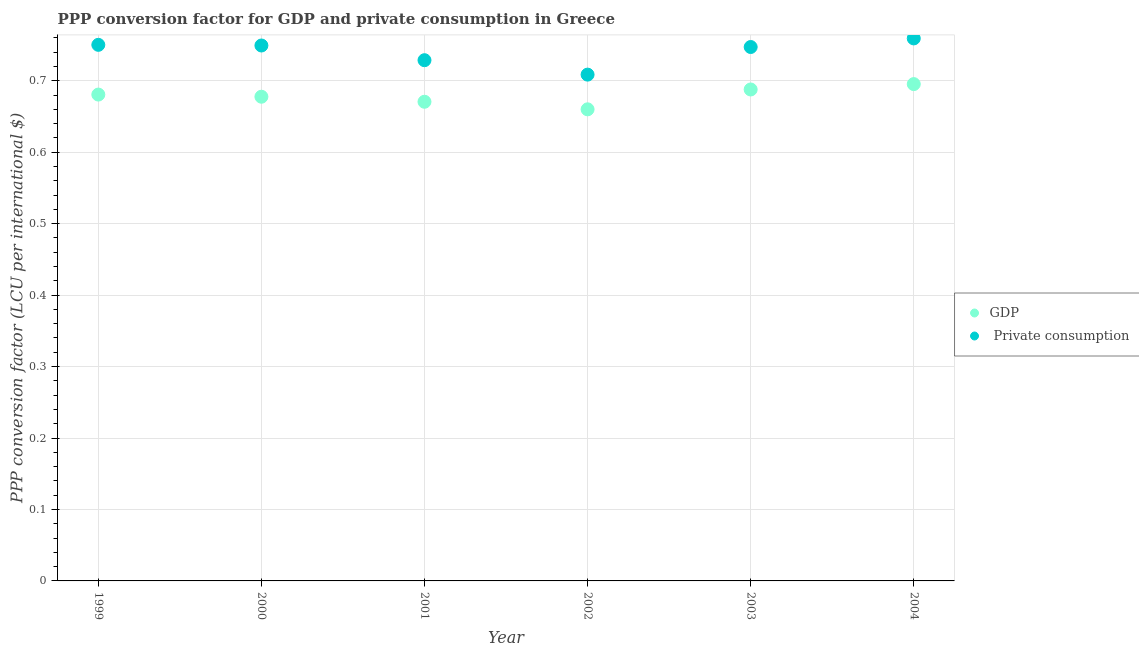How many different coloured dotlines are there?
Offer a very short reply. 2. Is the number of dotlines equal to the number of legend labels?
Give a very brief answer. Yes. What is the ppp conversion factor for private consumption in 2003?
Your answer should be compact. 0.75. Across all years, what is the maximum ppp conversion factor for private consumption?
Your response must be concise. 0.76. Across all years, what is the minimum ppp conversion factor for private consumption?
Your response must be concise. 0.71. In which year was the ppp conversion factor for gdp maximum?
Make the answer very short. 2004. What is the total ppp conversion factor for private consumption in the graph?
Your answer should be very brief. 4.44. What is the difference between the ppp conversion factor for gdp in 2001 and that in 2003?
Offer a terse response. -0.02. What is the difference between the ppp conversion factor for gdp in 2001 and the ppp conversion factor for private consumption in 2000?
Ensure brevity in your answer.  -0.08. What is the average ppp conversion factor for private consumption per year?
Offer a terse response. 0.74. In the year 2004, what is the difference between the ppp conversion factor for private consumption and ppp conversion factor for gdp?
Offer a very short reply. 0.06. What is the ratio of the ppp conversion factor for gdp in 2001 to that in 2004?
Provide a short and direct response. 0.96. Is the ppp conversion factor for gdp in 2000 less than that in 2004?
Give a very brief answer. Yes. What is the difference between the highest and the second highest ppp conversion factor for private consumption?
Offer a very short reply. 0.01. What is the difference between the highest and the lowest ppp conversion factor for gdp?
Ensure brevity in your answer.  0.04. Is the ppp conversion factor for gdp strictly less than the ppp conversion factor for private consumption over the years?
Provide a succinct answer. Yes. How many years are there in the graph?
Give a very brief answer. 6. What is the difference between two consecutive major ticks on the Y-axis?
Keep it short and to the point. 0.1. Does the graph contain grids?
Ensure brevity in your answer.  Yes. How are the legend labels stacked?
Offer a terse response. Vertical. What is the title of the graph?
Offer a terse response. PPP conversion factor for GDP and private consumption in Greece. Does "From World Bank" appear as one of the legend labels in the graph?
Your answer should be compact. No. What is the label or title of the Y-axis?
Ensure brevity in your answer.  PPP conversion factor (LCU per international $). What is the PPP conversion factor (LCU per international $) of GDP in 1999?
Provide a short and direct response. 0.68. What is the PPP conversion factor (LCU per international $) in  Private consumption in 1999?
Keep it short and to the point. 0.75. What is the PPP conversion factor (LCU per international $) of GDP in 2000?
Give a very brief answer. 0.68. What is the PPP conversion factor (LCU per international $) in  Private consumption in 2000?
Keep it short and to the point. 0.75. What is the PPP conversion factor (LCU per international $) in GDP in 2001?
Your answer should be very brief. 0.67. What is the PPP conversion factor (LCU per international $) in  Private consumption in 2001?
Provide a short and direct response. 0.73. What is the PPP conversion factor (LCU per international $) in GDP in 2002?
Ensure brevity in your answer.  0.66. What is the PPP conversion factor (LCU per international $) of  Private consumption in 2002?
Provide a succinct answer. 0.71. What is the PPP conversion factor (LCU per international $) of GDP in 2003?
Make the answer very short. 0.69. What is the PPP conversion factor (LCU per international $) of  Private consumption in 2003?
Offer a very short reply. 0.75. What is the PPP conversion factor (LCU per international $) of GDP in 2004?
Provide a short and direct response. 0.7. What is the PPP conversion factor (LCU per international $) of  Private consumption in 2004?
Make the answer very short. 0.76. Across all years, what is the maximum PPP conversion factor (LCU per international $) in GDP?
Provide a succinct answer. 0.7. Across all years, what is the maximum PPP conversion factor (LCU per international $) in  Private consumption?
Your answer should be very brief. 0.76. Across all years, what is the minimum PPP conversion factor (LCU per international $) of GDP?
Ensure brevity in your answer.  0.66. Across all years, what is the minimum PPP conversion factor (LCU per international $) in  Private consumption?
Make the answer very short. 0.71. What is the total PPP conversion factor (LCU per international $) in GDP in the graph?
Your answer should be very brief. 4.07. What is the total PPP conversion factor (LCU per international $) in  Private consumption in the graph?
Make the answer very short. 4.44. What is the difference between the PPP conversion factor (LCU per international $) of GDP in 1999 and that in 2000?
Ensure brevity in your answer.  0. What is the difference between the PPP conversion factor (LCU per international $) of  Private consumption in 1999 and that in 2000?
Your response must be concise. 0. What is the difference between the PPP conversion factor (LCU per international $) in GDP in 1999 and that in 2001?
Ensure brevity in your answer.  0.01. What is the difference between the PPP conversion factor (LCU per international $) of  Private consumption in 1999 and that in 2001?
Your answer should be very brief. 0.02. What is the difference between the PPP conversion factor (LCU per international $) of GDP in 1999 and that in 2002?
Provide a succinct answer. 0.02. What is the difference between the PPP conversion factor (LCU per international $) of  Private consumption in 1999 and that in 2002?
Your answer should be very brief. 0.04. What is the difference between the PPP conversion factor (LCU per international $) of GDP in 1999 and that in 2003?
Give a very brief answer. -0.01. What is the difference between the PPP conversion factor (LCU per international $) in  Private consumption in 1999 and that in 2003?
Give a very brief answer. 0. What is the difference between the PPP conversion factor (LCU per international $) of GDP in 1999 and that in 2004?
Ensure brevity in your answer.  -0.01. What is the difference between the PPP conversion factor (LCU per international $) of  Private consumption in 1999 and that in 2004?
Give a very brief answer. -0.01. What is the difference between the PPP conversion factor (LCU per international $) of GDP in 2000 and that in 2001?
Offer a very short reply. 0.01. What is the difference between the PPP conversion factor (LCU per international $) of  Private consumption in 2000 and that in 2001?
Make the answer very short. 0.02. What is the difference between the PPP conversion factor (LCU per international $) of GDP in 2000 and that in 2002?
Provide a short and direct response. 0.02. What is the difference between the PPP conversion factor (LCU per international $) of  Private consumption in 2000 and that in 2002?
Provide a succinct answer. 0.04. What is the difference between the PPP conversion factor (LCU per international $) in GDP in 2000 and that in 2003?
Make the answer very short. -0.01. What is the difference between the PPP conversion factor (LCU per international $) of  Private consumption in 2000 and that in 2003?
Provide a succinct answer. 0. What is the difference between the PPP conversion factor (LCU per international $) in GDP in 2000 and that in 2004?
Give a very brief answer. -0.02. What is the difference between the PPP conversion factor (LCU per international $) of  Private consumption in 2000 and that in 2004?
Provide a short and direct response. -0.01. What is the difference between the PPP conversion factor (LCU per international $) in GDP in 2001 and that in 2002?
Your response must be concise. 0.01. What is the difference between the PPP conversion factor (LCU per international $) of  Private consumption in 2001 and that in 2002?
Give a very brief answer. 0.02. What is the difference between the PPP conversion factor (LCU per international $) in GDP in 2001 and that in 2003?
Provide a succinct answer. -0.02. What is the difference between the PPP conversion factor (LCU per international $) of  Private consumption in 2001 and that in 2003?
Ensure brevity in your answer.  -0.02. What is the difference between the PPP conversion factor (LCU per international $) in GDP in 2001 and that in 2004?
Provide a short and direct response. -0.02. What is the difference between the PPP conversion factor (LCU per international $) of  Private consumption in 2001 and that in 2004?
Your response must be concise. -0.03. What is the difference between the PPP conversion factor (LCU per international $) in GDP in 2002 and that in 2003?
Your answer should be compact. -0.03. What is the difference between the PPP conversion factor (LCU per international $) in  Private consumption in 2002 and that in 2003?
Your response must be concise. -0.04. What is the difference between the PPP conversion factor (LCU per international $) of GDP in 2002 and that in 2004?
Your answer should be very brief. -0.04. What is the difference between the PPP conversion factor (LCU per international $) in  Private consumption in 2002 and that in 2004?
Ensure brevity in your answer.  -0.05. What is the difference between the PPP conversion factor (LCU per international $) of GDP in 2003 and that in 2004?
Provide a succinct answer. -0.01. What is the difference between the PPP conversion factor (LCU per international $) of  Private consumption in 2003 and that in 2004?
Provide a short and direct response. -0.01. What is the difference between the PPP conversion factor (LCU per international $) of GDP in 1999 and the PPP conversion factor (LCU per international $) of  Private consumption in 2000?
Ensure brevity in your answer.  -0.07. What is the difference between the PPP conversion factor (LCU per international $) of GDP in 1999 and the PPP conversion factor (LCU per international $) of  Private consumption in 2001?
Your answer should be compact. -0.05. What is the difference between the PPP conversion factor (LCU per international $) in GDP in 1999 and the PPP conversion factor (LCU per international $) in  Private consumption in 2002?
Give a very brief answer. -0.03. What is the difference between the PPP conversion factor (LCU per international $) in GDP in 1999 and the PPP conversion factor (LCU per international $) in  Private consumption in 2003?
Give a very brief answer. -0.07. What is the difference between the PPP conversion factor (LCU per international $) in GDP in 1999 and the PPP conversion factor (LCU per international $) in  Private consumption in 2004?
Make the answer very short. -0.08. What is the difference between the PPP conversion factor (LCU per international $) in GDP in 2000 and the PPP conversion factor (LCU per international $) in  Private consumption in 2001?
Your answer should be very brief. -0.05. What is the difference between the PPP conversion factor (LCU per international $) of GDP in 2000 and the PPP conversion factor (LCU per international $) of  Private consumption in 2002?
Provide a short and direct response. -0.03. What is the difference between the PPP conversion factor (LCU per international $) of GDP in 2000 and the PPP conversion factor (LCU per international $) of  Private consumption in 2003?
Keep it short and to the point. -0.07. What is the difference between the PPP conversion factor (LCU per international $) in GDP in 2000 and the PPP conversion factor (LCU per international $) in  Private consumption in 2004?
Your answer should be very brief. -0.08. What is the difference between the PPP conversion factor (LCU per international $) in GDP in 2001 and the PPP conversion factor (LCU per international $) in  Private consumption in 2002?
Make the answer very short. -0.04. What is the difference between the PPP conversion factor (LCU per international $) of GDP in 2001 and the PPP conversion factor (LCU per international $) of  Private consumption in 2003?
Your response must be concise. -0.08. What is the difference between the PPP conversion factor (LCU per international $) of GDP in 2001 and the PPP conversion factor (LCU per international $) of  Private consumption in 2004?
Your answer should be compact. -0.09. What is the difference between the PPP conversion factor (LCU per international $) of GDP in 2002 and the PPP conversion factor (LCU per international $) of  Private consumption in 2003?
Offer a terse response. -0.09. What is the difference between the PPP conversion factor (LCU per international $) in GDP in 2002 and the PPP conversion factor (LCU per international $) in  Private consumption in 2004?
Ensure brevity in your answer.  -0.1. What is the difference between the PPP conversion factor (LCU per international $) of GDP in 2003 and the PPP conversion factor (LCU per international $) of  Private consumption in 2004?
Keep it short and to the point. -0.07. What is the average PPP conversion factor (LCU per international $) in GDP per year?
Provide a short and direct response. 0.68. What is the average PPP conversion factor (LCU per international $) in  Private consumption per year?
Provide a succinct answer. 0.74. In the year 1999, what is the difference between the PPP conversion factor (LCU per international $) in GDP and PPP conversion factor (LCU per international $) in  Private consumption?
Provide a short and direct response. -0.07. In the year 2000, what is the difference between the PPP conversion factor (LCU per international $) of GDP and PPP conversion factor (LCU per international $) of  Private consumption?
Make the answer very short. -0.07. In the year 2001, what is the difference between the PPP conversion factor (LCU per international $) of GDP and PPP conversion factor (LCU per international $) of  Private consumption?
Make the answer very short. -0.06. In the year 2002, what is the difference between the PPP conversion factor (LCU per international $) in GDP and PPP conversion factor (LCU per international $) in  Private consumption?
Offer a terse response. -0.05. In the year 2003, what is the difference between the PPP conversion factor (LCU per international $) of GDP and PPP conversion factor (LCU per international $) of  Private consumption?
Give a very brief answer. -0.06. In the year 2004, what is the difference between the PPP conversion factor (LCU per international $) of GDP and PPP conversion factor (LCU per international $) of  Private consumption?
Your answer should be compact. -0.06. What is the ratio of the PPP conversion factor (LCU per international $) of GDP in 1999 to that in 2000?
Offer a terse response. 1. What is the ratio of the PPP conversion factor (LCU per international $) of GDP in 1999 to that in 2001?
Offer a very short reply. 1.01. What is the ratio of the PPP conversion factor (LCU per international $) of  Private consumption in 1999 to that in 2001?
Offer a very short reply. 1.03. What is the ratio of the PPP conversion factor (LCU per international $) of GDP in 1999 to that in 2002?
Give a very brief answer. 1.03. What is the ratio of the PPP conversion factor (LCU per international $) in  Private consumption in 1999 to that in 2002?
Your answer should be compact. 1.06. What is the ratio of the PPP conversion factor (LCU per international $) in GDP in 1999 to that in 2003?
Make the answer very short. 0.99. What is the ratio of the PPP conversion factor (LCU per international $) in GDP in 1999 to that in 2004?
Your answer should be very brief. 0.98. What is the ratio of the PPP conversion factor (LCU per international $) of GDP in 2000 to that in 2001?
Offer a terse response. 1.01. What is the ratio of the PPP conversion factor (LCU per international $) in  Private consumption in 2000 to that in 2001?
Give a very brief answer. 1.03. What is the ratio of the PPP conversion factor (LCU per international $) in GDP in 2000 to that in 2002?
Your answer should be compact. 1.03. What is the ratio of the PPP conversion factor (LCU per international $) of  Private consumption in 2000 to that in 2002?
Offer a very short reply. 1.06. What is the ratio of the PPP conversion factor (LCU per international $) in  Private consumption in 2000 to that in 2003?
Ensure brevity in your answer.  1. What is the ratio of the PPP conversion factor (LCU per international $) of GDP in 2000 to that in 2004?
Provide a succinct answer. 0.97. What is the ratio of the PPP conversion factor (LCU per international $) in  Private consumption in 2000 to that in 2004?
Ensure brevity in your answer.  0.99. What is the ratio of the PPP conversion factor (LCU per international $) of  Private consumption in 2001 to that in 2002?
Your answer should be compact. 1.03. What is the ratio of the PPP conversion factor (LCU per international $) in GDP in 2001 to that in 2003?
Offer a very short reply. 0.97. What is the ratio of the PPP conversion factor (LCU per international $) in  Private consumption in 2001 to that in 2003?
Offer a terse response. 0.98. What is the ratio of the PPP conversion factor (LCU per international $) in GDP in 2001 to that in 2004?
Provide a short and direct response. 0.96. What is the ratio of the PPP conversion factor (LCU per international $) of  Private consumption in 2001 to that in 2004?
Give a very brief answer. 0.96. What is the ratio of the PPP conversion factor (LCU per international $) in GDP in 2002 to that in 2003?
Your response must be concise. 0.96. What is the ratio of the PPP conversion factor (LCU per international $) in  Private consumption in 2002 to that in 2003?
Offer a terse response. 0.95. What is the ratio of the PPP conversion factor (LCU per international $) of GDP in 2002 to that in 2004?
Offer a terse response. 0.95. What is the ratio of the PPP conversion factor (LCU per international $) of GDP in 2003 to that in 2004?
Provide a short and direct response. 0.99. What is the ratio of the PPP conversion factor (LCU per international $) in  Private consumption in 2003 to that in 2004?
Your answer should be compact. 0.98. What is the difference between the highest and the second highest PPP conversion factor (LCU per international $) in GDP?
Offer a very short reply. 0.01. What is the difference between the highest and the second highest PPP conversion factor (LCU per international $) of  Private consumption?
Provide a succinct answer. 0.01. What is the difference between the highest and the lowest PPP conversion factor (LCU per international $) in GDP?
Provide a succinct answer. 0.04. What is the difference between the highest and the lowest PPP conversion factor (LCU per international $) of  Private consumption?
Your response must be concise. 0.05. 